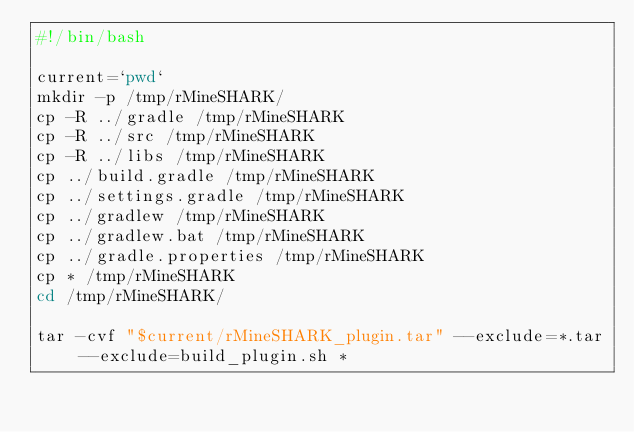<code> <loc_0><loc_0><loc_500><loc_500><_Bash_>#!/bin/bash

current=`pwd`
mkdir -p /tmp/rMineSHARK/
cp -R ../gradle /tmp/rMineSHARK
cp -R ../src /tmp/rMineSHARK
cp -R ../libs /tmp/rMineSHARK
cp ../build.gradle /tmp/rMineSHARK 
cp ../settings.gradle /tmp/rMineSHARK
cp ../gradlew /tmp/rMineSHARK
cp ../gradlew.bat /tmp/rMineSHARK
cp ../gradle.properties /tmp/rMineSHARK
cp * /tmp/rMineSHARK
cd /tmp/rMineSHARK/

tar -cvf "$current/rMineSHARK_plugin.tar" --exclude=*.tar --exclude=build_plugin.sh *</code> 